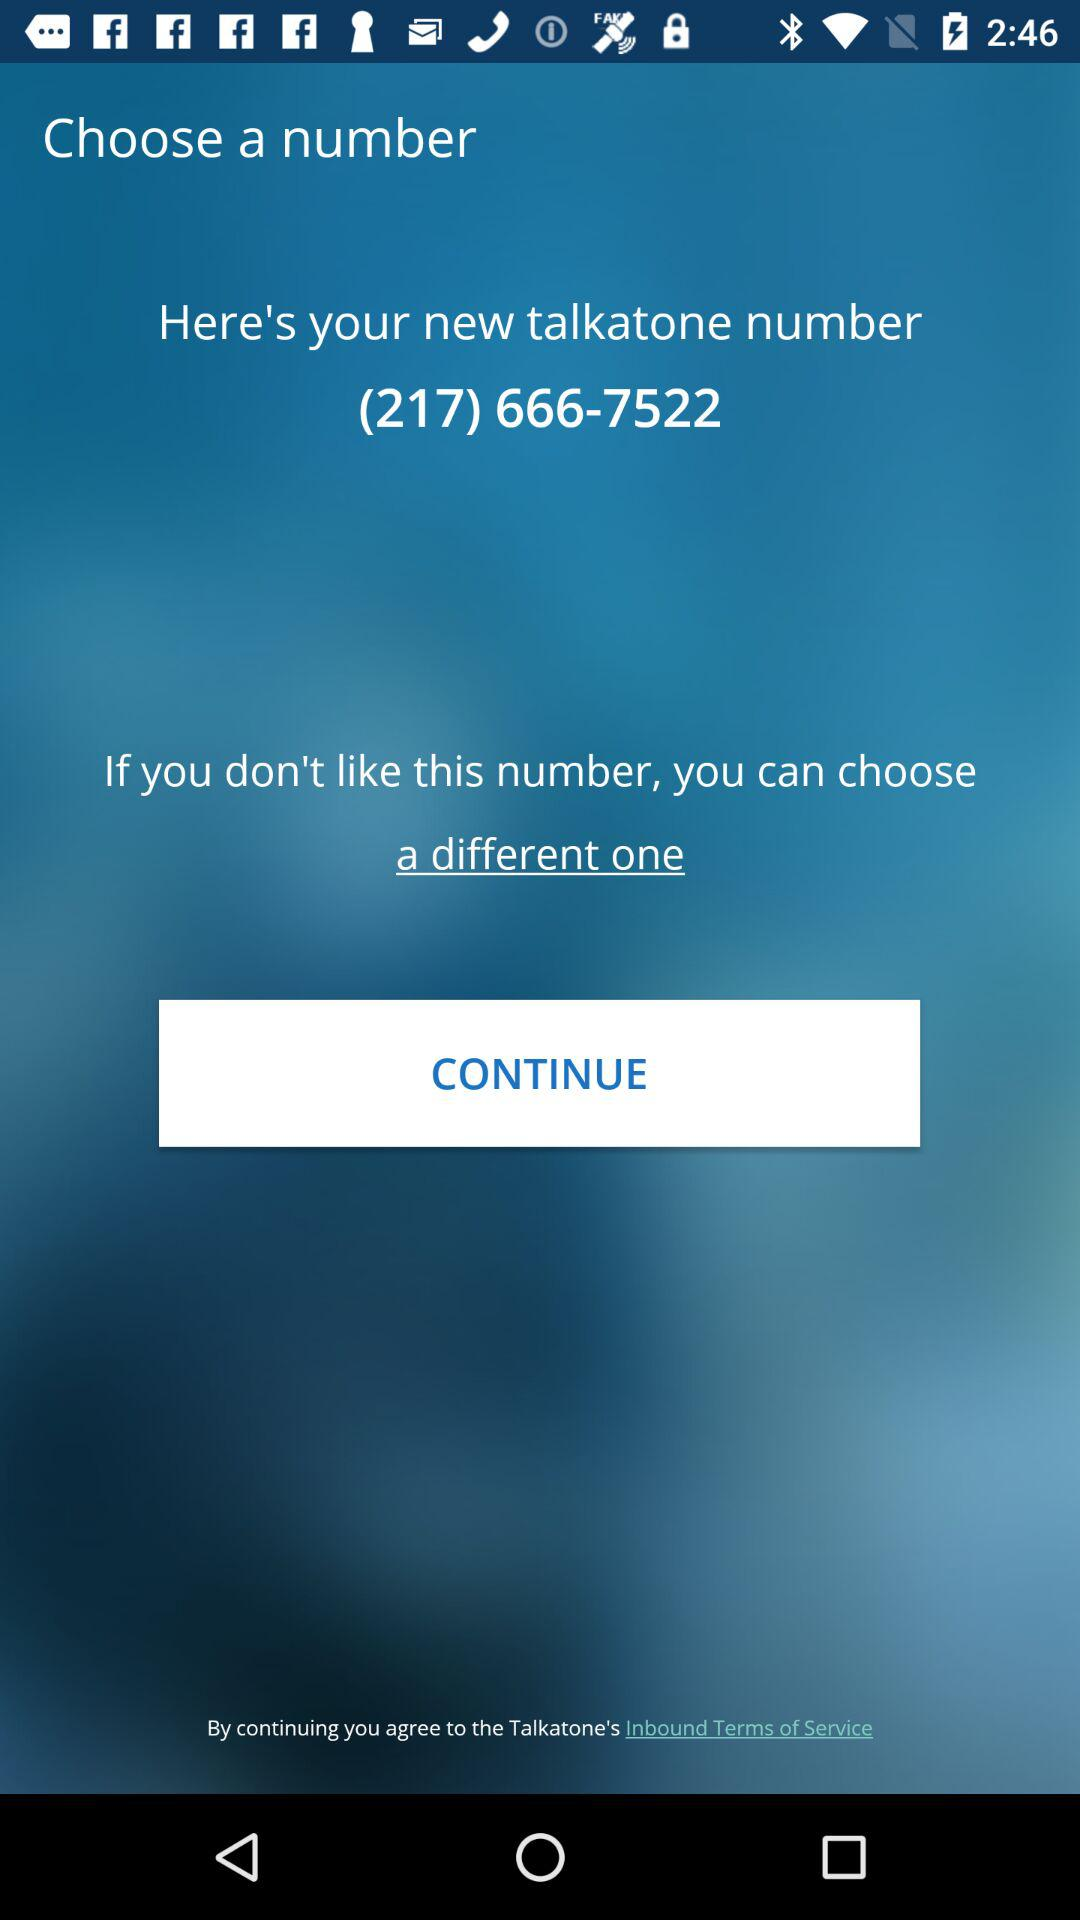What is the contact number? The contact number is (217) 666-7522. 